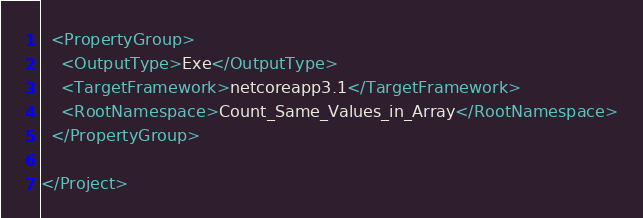<code> <loc_0><loc_0><loc_500><loc_500><_XML_>
  <PropertyGroup>
    <OutputType>Exe</OutputType>
    <TargetFramework>netcoreapp3.1</TargetFramework>
    <RootNamespace>Count_Same_Values_in_Array</RootNamespace>
  </PropertyGroup>

</Project>
</code> 